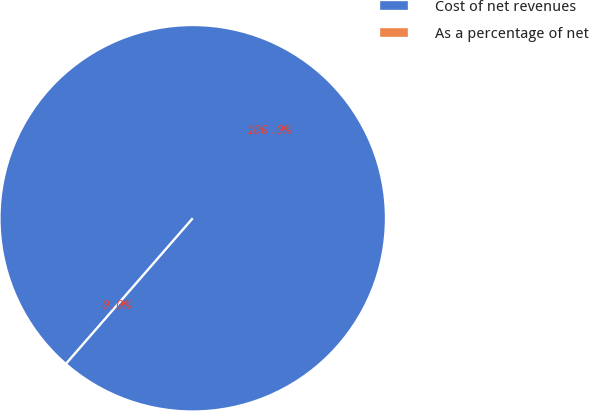Convert chart to OTSL. <chart><loc_0><loc_0><loc_500><loc_500><pie_chart><fcel>Cost of net revenues<fcel>As a percentage of net<nl><fcel>100.0%<fcel>0.0%<nl></chart> 